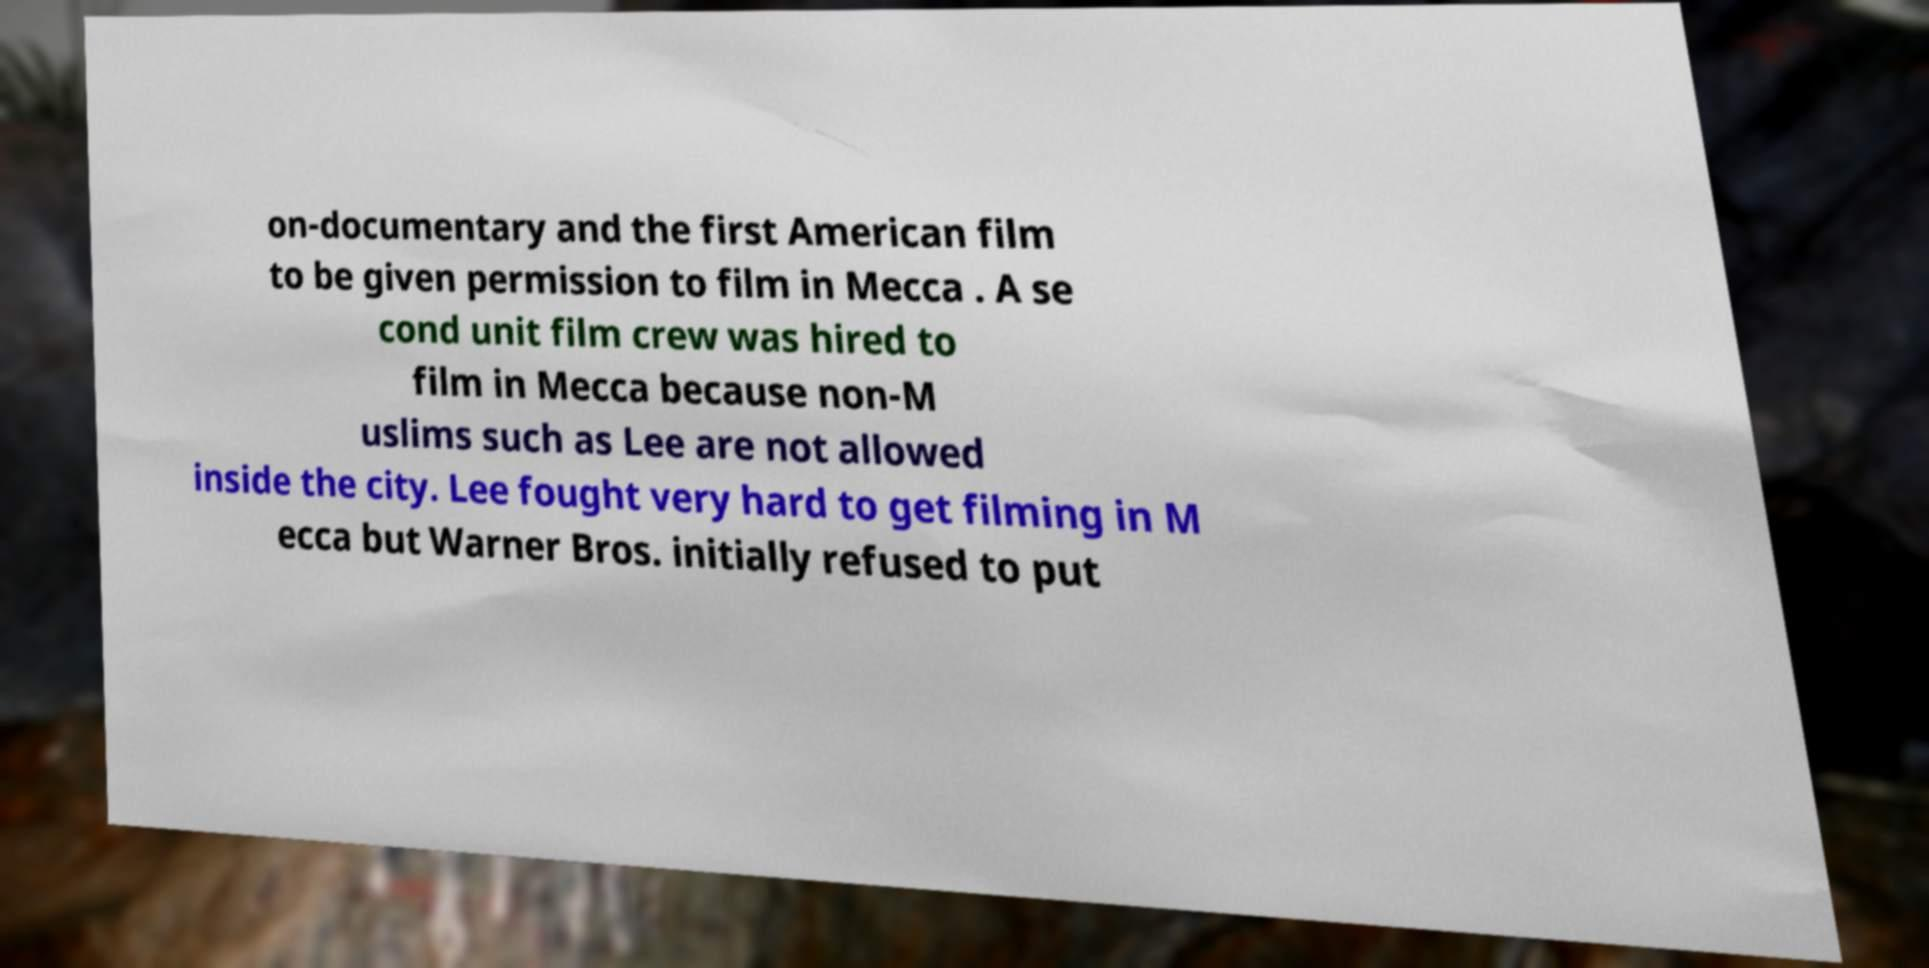Could you assist in decoding the text presented in this image and type it out clearly? on-documentary and the first American film to be given permission to film in Mecca . A se cond unit film crew was hired to film in Mecca because non-M uslims such as Lee are not allowed inside the city. Lee fought very hard to get filming in M ecca but Warner Bros. initially refused to put 